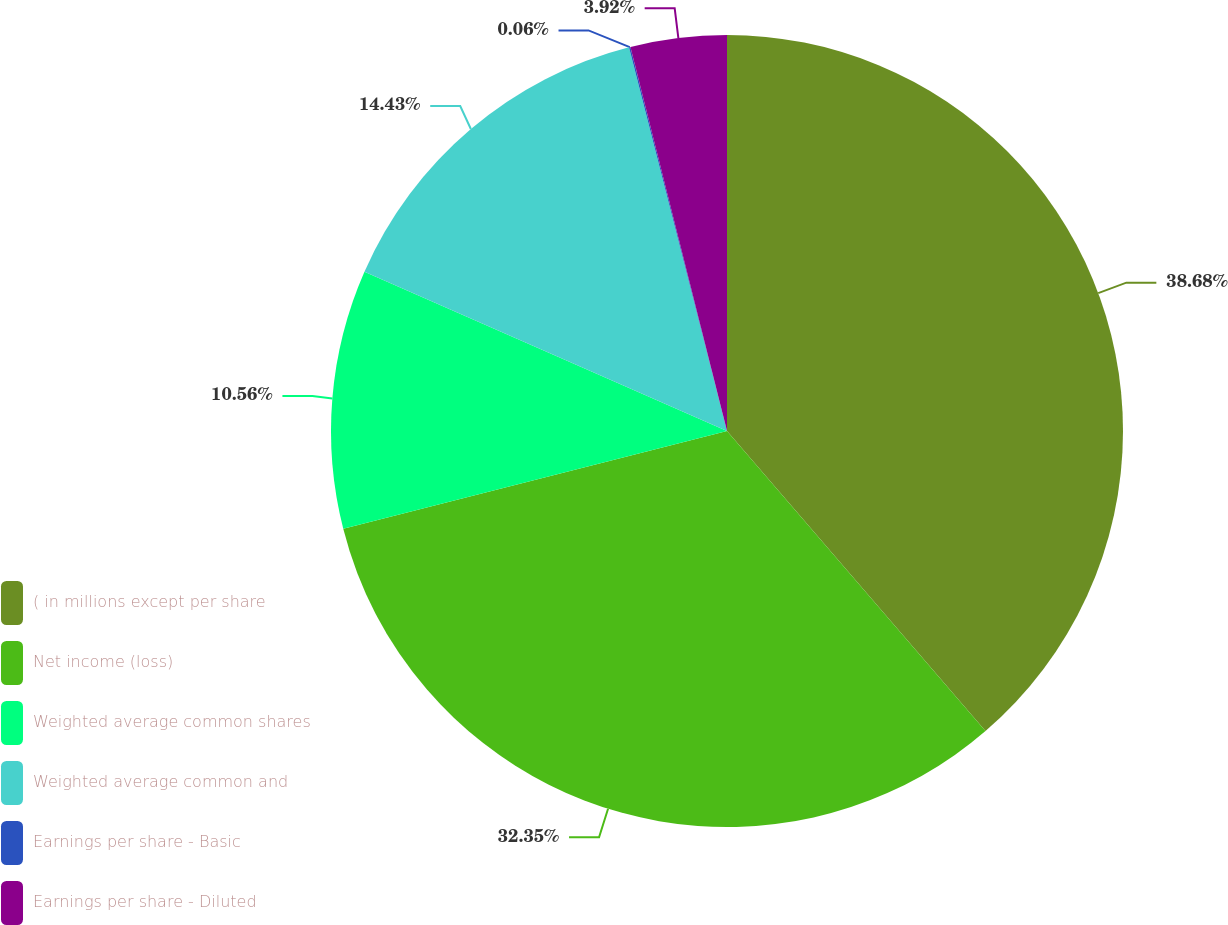Convert chart. <chart><loc_0><loc_0><loc_500><loc_500><pie_chart><fcel>( in millions except per share<fcel>Net income (loss)<fcel>Weighted average common shares<fcel>Weighted average common and<fcel>Earnings per share - Basic<fcel>Earnings per share - Diluted<nl><fcel>38.68%<fcel>32.35%<fcel>10.56%<fcel>14.43%<fcel>0.06%<fcel>3.92%<nl></chart> 